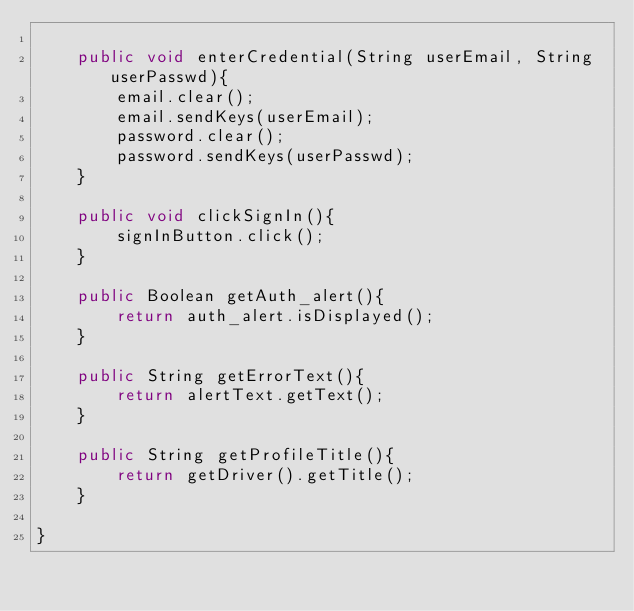<code> <loc_0><loc_0><loc_500><loc_500><_Java_>
    public void enterCredential(String userEmail, String userPasswd){
        email.clear();
        email.sendKeys(userEmail);
        password.clear();
        password.sendKeys(userPasswd);
    }

    public void clickSignIn(){
        signInButton.click();
    }

    public Boolean getAuth_alert(){
        return auth_alert.isDisplayed();
    }

    public String getErrorText(){
        return alertText.getText();
    }

    public String getProfileTitle(){
        return getDriver().getTitle();
    }

}
</code> 